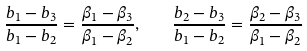<formula> <loc_0><loc_0><loc_500><loc_500>\frac { b _ { 1 } - b _ { 3 } } { b _ { 1 } - b _ { 2 } } = \frac { \beta _ { 1 } - \beta _ { 3 } } { \beta _ { 1 } - \beta _ { 2 } } , \quad \frac { b _ { 2 } - b _ { 3 } } { b _ { 1 } - b _ { 2 } } = \frac { \beta _ { 2 } - \beta _ { 3 } } { \beta _ { 1 } - \beta _ { 2 } }</formula> 